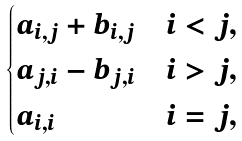Convert formula to latex. <formula><loc_0><loc_0><loc_500><loc_500>\begin{cases} a _ { i , j } + b _ { i , j } & i < j , \\ a _ { j , i } - b _ { j , i } & i > j , \\ a _ { i , i } & i = j , \end{cases}</formula> 